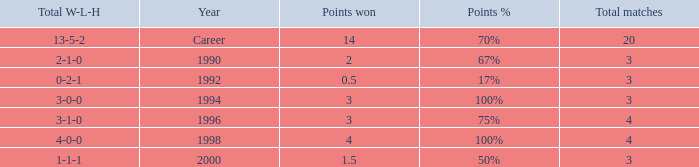Can you tell me the lowest Total natches that has the Points won of 3, and the Year of 1994? 3.0. 